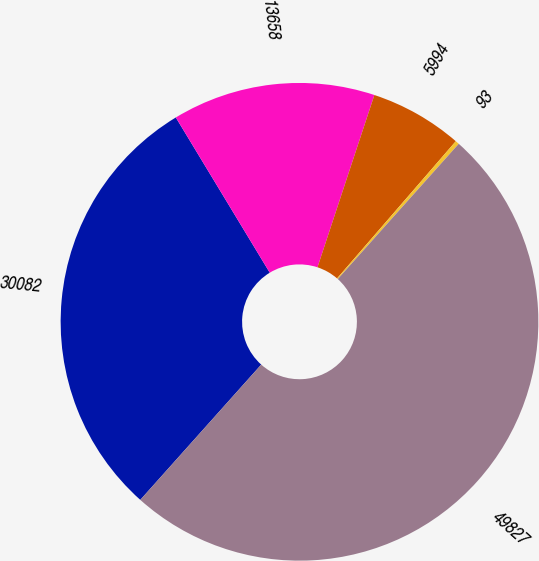<chart> <loc_0><loc_0><loc_500><loc_500><pie_chart><fcel>30082<fcel>13658<fcel>5994<fcel>93<fcel>49827<nl><fcel>29.73%<fcel>13.74%<fcel>6.28%<fcel>0.26%<fcel>50.0%<nl></chart> 